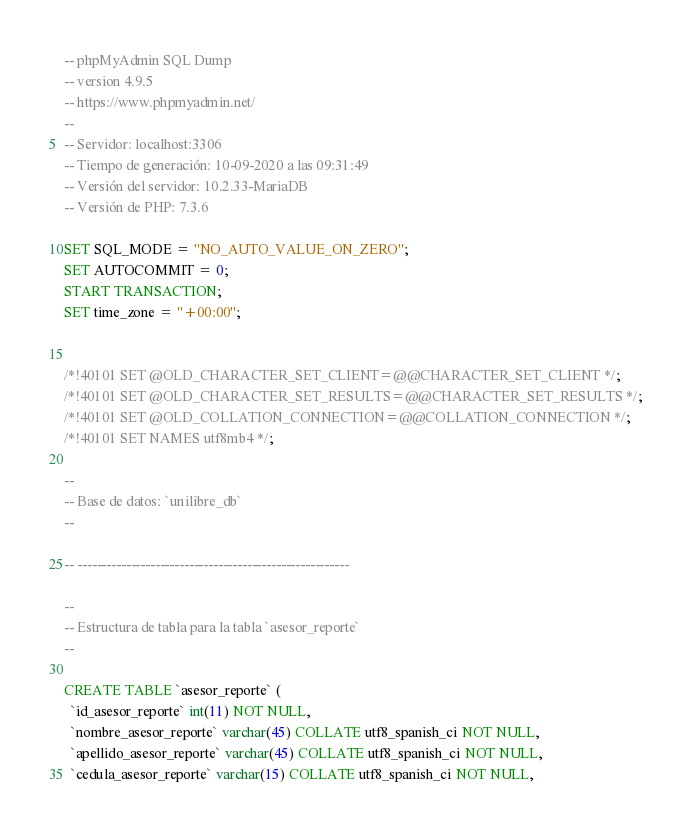Convert code to text. <code><loc_0><loc_0><loc_500><loc_500><_SQL_>-- phpMyAdmin SQL Dump
-- version 4.9.5
-- https://www.phpmyadmin.net/
--
-- Servidor: localhost:3306
-- Tiempo de generación: 10-09-2020 a las 09:31:49
-- Versión del servidor: 10.2.33-MariaDB
-- Versión de PHP: 7.3.6

SET SQL_MODE = "NO_AUTO_VALUE_ON_ZERO";
SET AUTOCOMMIT = 0;
START TRANSACTION;
SET time_zone = "+00:00";


/*!40101 SET @OLD_CHARACTER_SET_CLIENT=@@CHARACTER_SET_CLIENT */;
/*!40101 SET @OLD_CHARACTER_SET_RESULTS=@@CHARACTER_SET_RESULTS */;
/*!40101 SET @OLD_COLLATION_CONNECTION=@@COLLATION_CONNECTION */;
/*!40101 SET NAMES utf8mb4 */;

--
-- Base de datos: `unilibre_db`
--

-- --------------------------------------------------------

--
-- Estructura de tabla para la tabla `asesor_reporte`
--

CREATE TABLE `asesor_reporte` (
  `id_asesor_reporte` int(11) NOT NULL,
  `nombre_asesor_reporte` varchar(45) COLLATE utf8_spanish_ci NOT NULL,
  `apellido_asesor_reporte` varchar(45) COLLATE utf8_spanish_ci NOT NULL,
  `cedula_asesor_reporte` varchar(15) COLLATE utf8_spanish_ci NOT NULL,</code> 